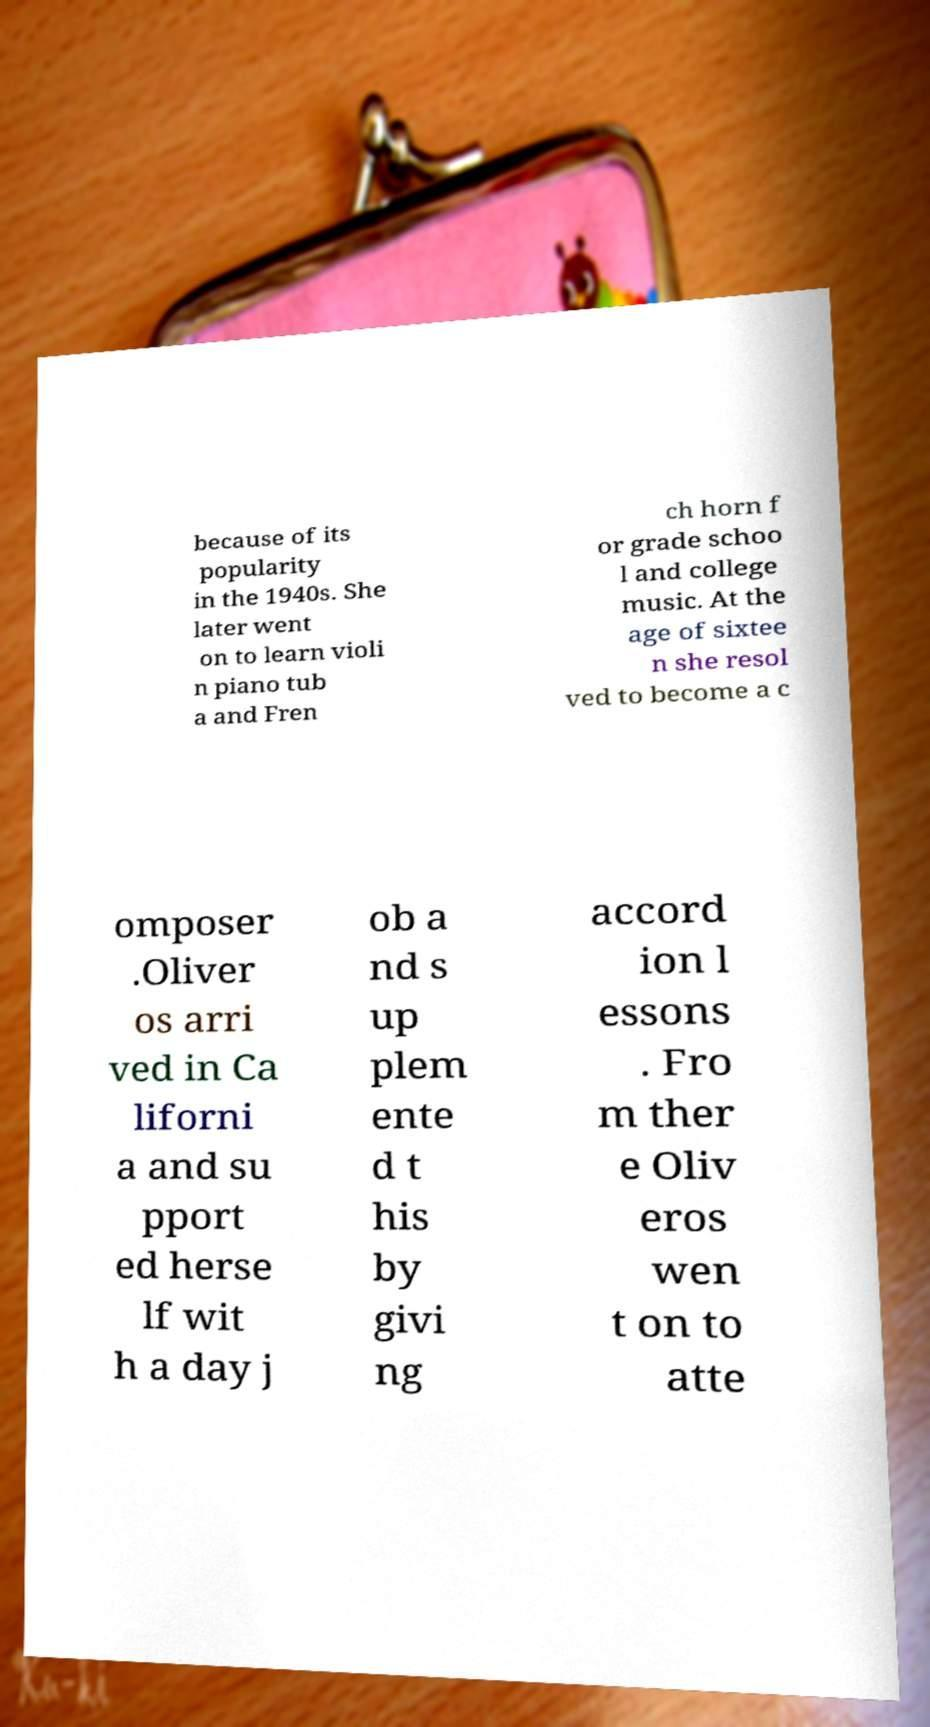For documentation purposes, I need the text within this image transcribed. Could you provide that? because of its popularity in the 1940s. She later went on to learn violi n piano tub a and Fren ch horn f or grade schoo l and college music. At the age of sixtee n she resol ved to become a c omposer .Oliver os arri ved in Ca liforni a and su pport ed herse lf wit h a day j ob a nd s up plem ente d t his by givi ng accord ion l essons . Fro m ther e Oliv eros wen t on to atte 